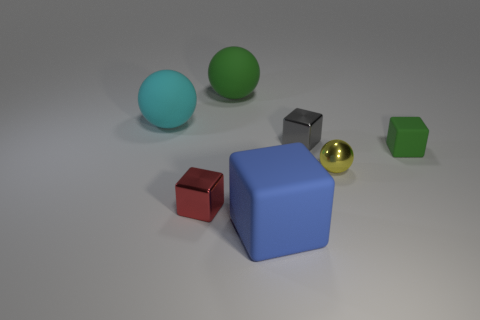Subtract 1 cubes. How many cubes are left? 3 Add 2 small red cubes. How many objects exist? 9 Subtract all brown blocks. Subtract all cyan spheres. How many blocks are left? 4 Subtract all cubes. How many objects are left? 3 Subtract all tiny green shiny cylinders. Subtract all large green balls. How many objects are left? 6 Add 1 red shiny objects. How many red shiny objects are left? 2 Add 4 small blue blocks. How many small blue blocks exist? 4 Subtract 0 purple balls. How many objects are left? 7 